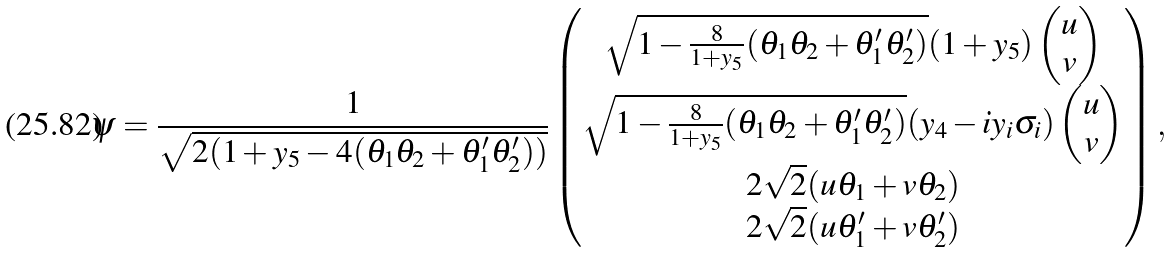<formula> <loc_0><loc_0><loc_500><loc_500>\psi = \frac { 1 } { \sqrt { 2 ( 1 + y _ { 5 } - 4 ( \theta _ { 1 } \theta _ { 2 } + \theta _ { 1 } ^ { \prime } \theta _ { 2 } ^ { \prime } ) ) } } \begin{pmatrix} { \sqrt { { 1 - \frac { 8 } { 1 + y _ { 5 } } ( \theta _ { 1 } \theta _ { 2 } + \theta _ { 1 } ^ { \prime } \theta _ { 2 } ^ { \prime } ) } } } ( 1 + y _ { 5 } ) \begin{pmatrix} u \\ v \end{pmatrix} \\ { \sqrt { { 1 - \frac { 8 } { 1 + y _ { 5 } } ( \theta _ { 1 } \theta _ { 2 } + \theta _ { 1 } ^ { \prime } \theta _ { 2 } ^ { \prime } ) } } ( y _ { 4 } - i y _ { i } \sigma _ { i } ) } \begin{pmatrix} u \\ v \end{pmatrix} \\ 2 \sqrt { 2 } ( u \theta _ { 1 } + v \theta _ { 2 } ) \\ 2 \sqrt { 2 } ( u \theta ^ { \prime } _ { 1 } + v \theta ^ { \prime } _ { 2 } ) \\ \end{pmatrix} ,</formula> 